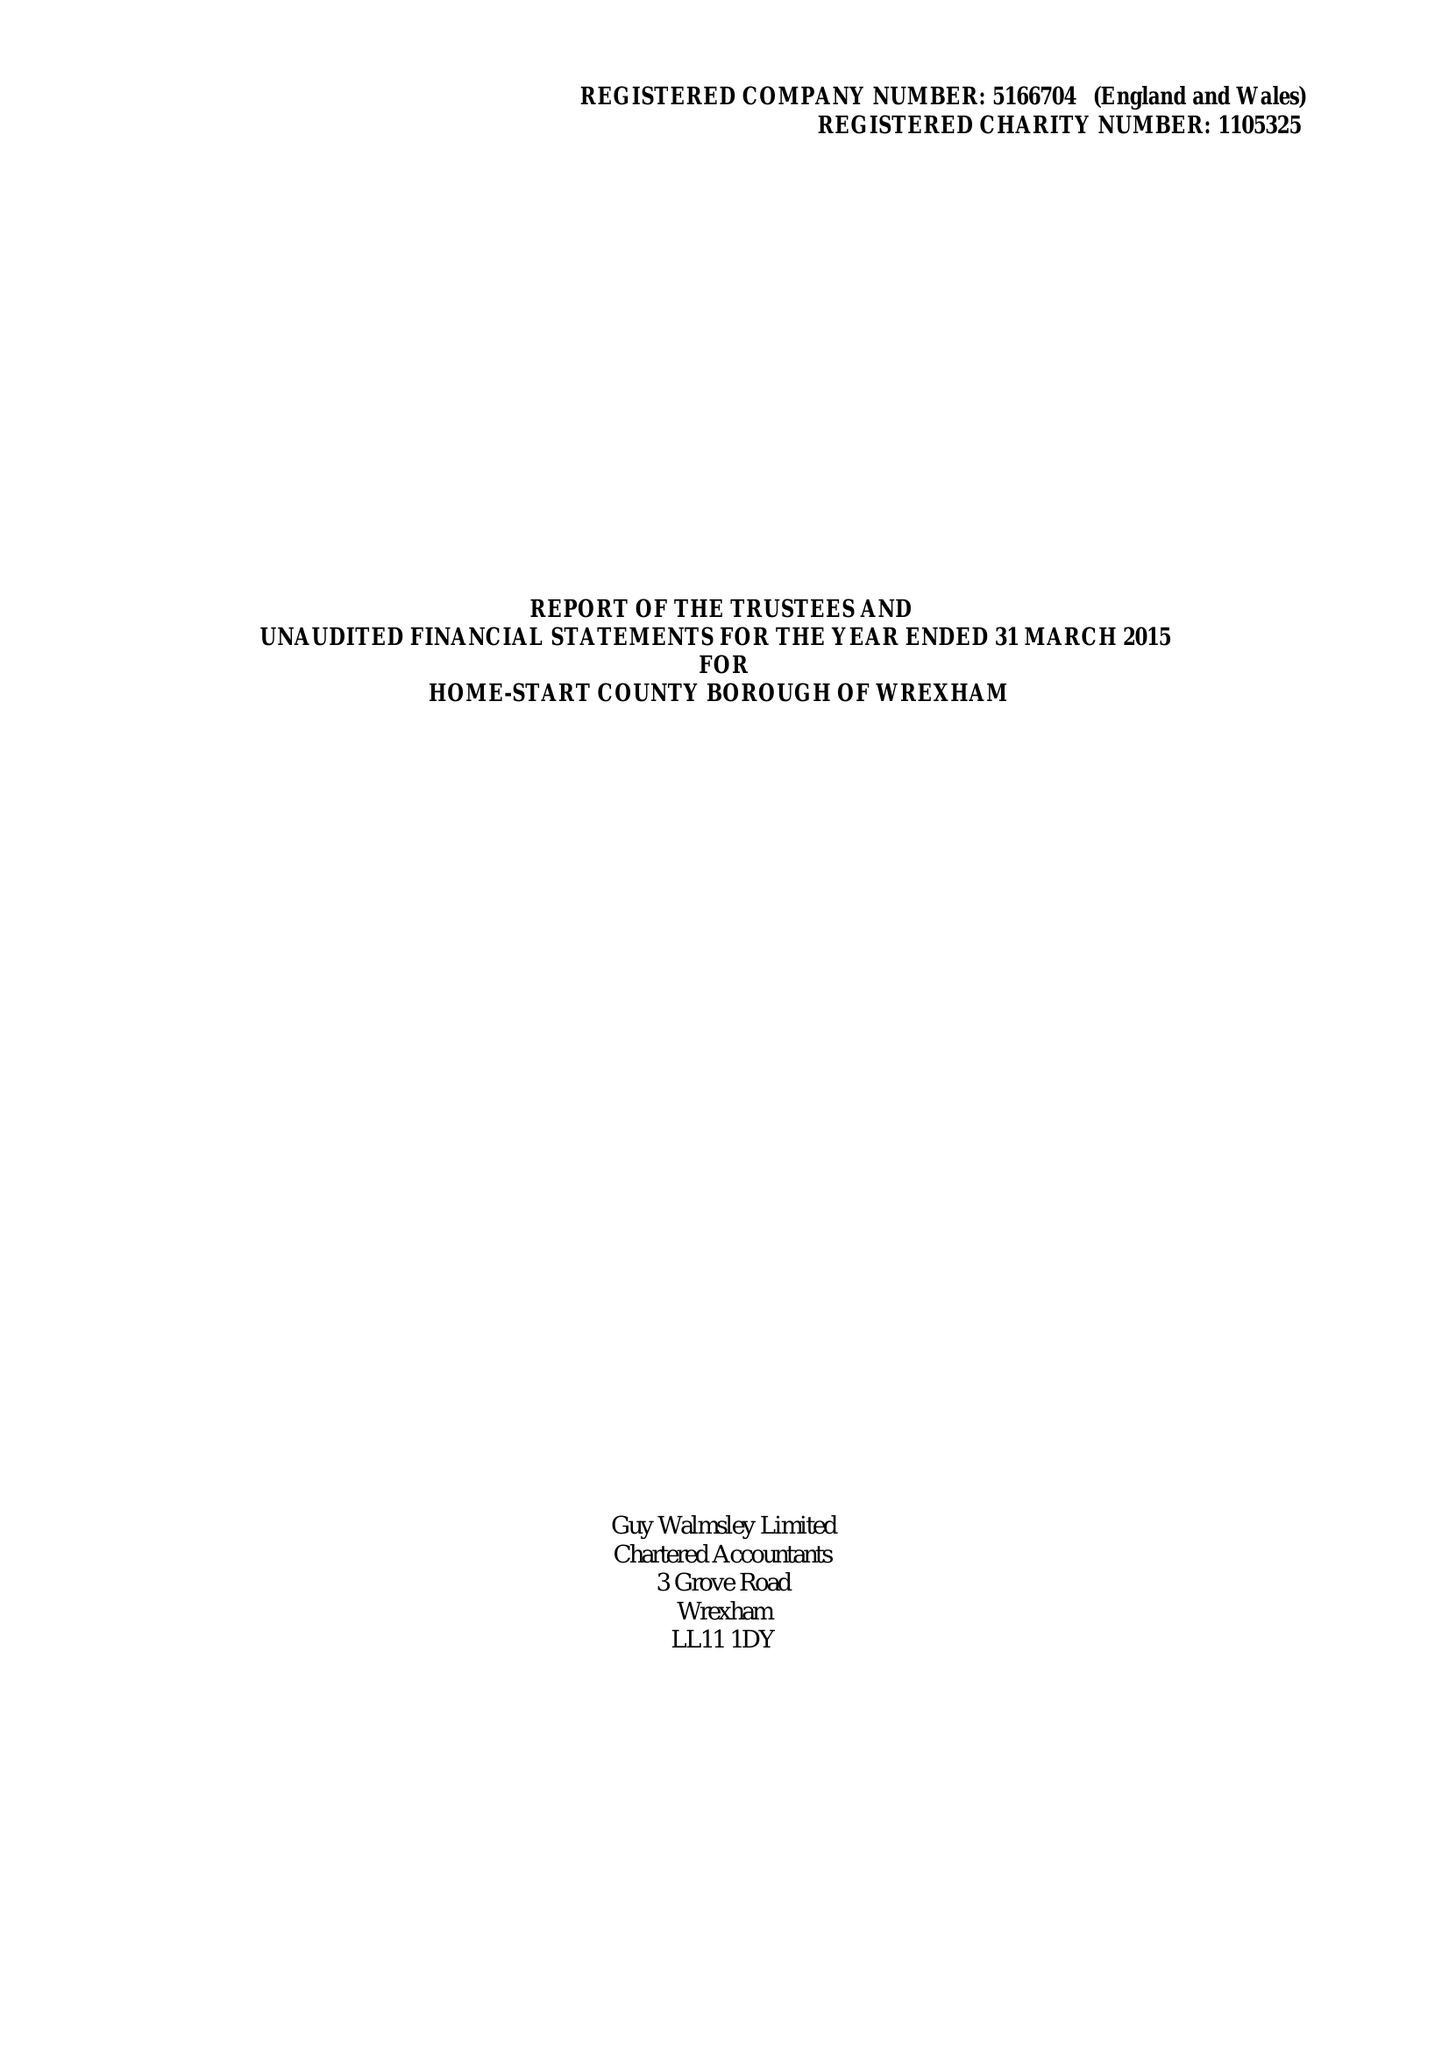What is the value for the charity_number?
Answer the question using a single word or phrase. 1105325 